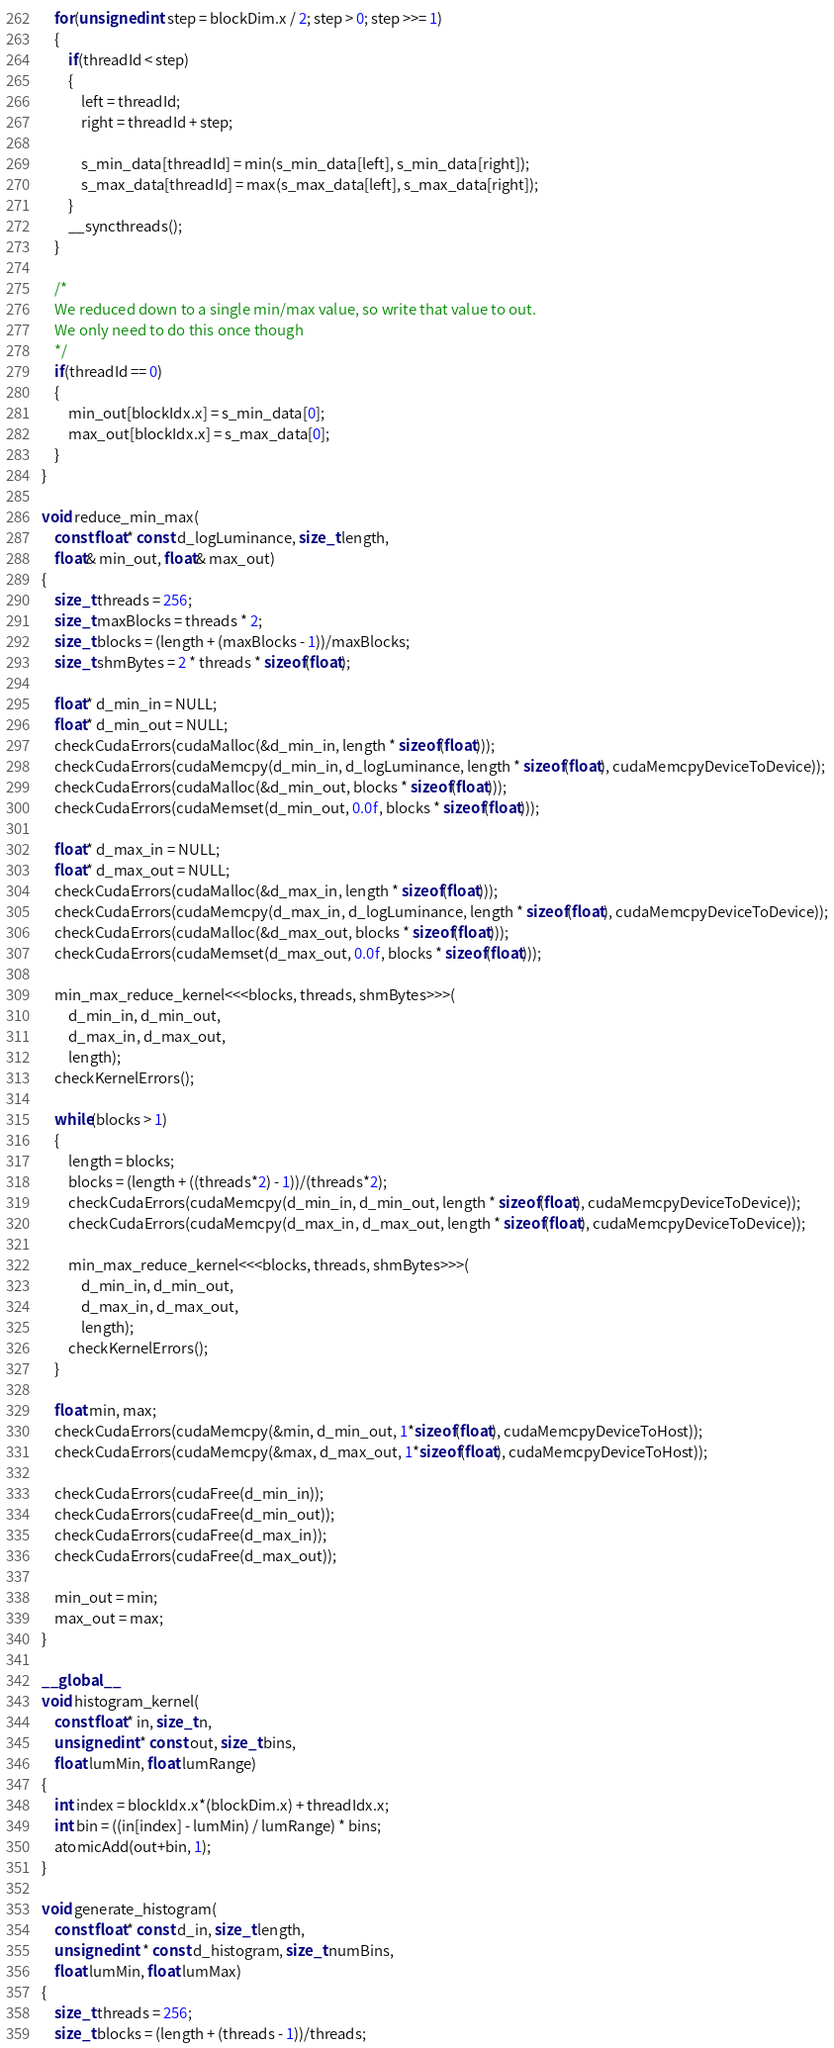<code> <loc_0><loc_0><loc_500><loc_500><_Cuda_>    for(unsigned int step = blockDim.x / 2; step > 0; step >>= 1)
    {
        if(threadId < step)
        {
            left = threadId;
            right = threadId + step;

            s_min_data[threadId] = min(s_min_data[left], s_min_data[right]);
            s_max_data[threadId] = max(s_max_data[left], s_max_data[right]);
        }
        __syncthreads();
    }

    /*
    We reduced down to a single min/max value, so write that value to out.
    We only need to do this once though
    */
    if(threadId == 0)
    {
        min_out[blockIdx.x] = s_min_data[0];
        max_out[blockIdx.x] = s_max_data[0];
    }
}

void reduce_min_max(
    const float* const d_logLuminance, size_t length,
    float& min_out, float& max_out)
{
    size_t threads = 256;
    size_t maxBlocks = threads * 2;
    size_t blocks = (length + (maxBlocks - 1))/maxBlocks;
    size_t shmBytes = 2 * threads * sizeof(float);

    float* d_min_in = NULL;
    float* d_min_out = NULL;
    checkCudaErrors(cudaMalloc(&d_min_in, length * sizeof(float)));
    checkCudaErrors(cudaMemcpy(d_min_in, d_logLuminance, length * sizeof(float), cudaMemcpyDeviceToDevice));
    checkCudaErrors(cudaMalloc(&d_min_out, blocks * sizeof(float)));
    checkCudaErrors(cudaMemset(d_min_out, 0.0f, blocks * sizeof(float)));

    float* d_max_in = NULL;
    float* d_max_out = NULL;
    checkCudaErrors(cudaMalloc(&d_max_in, length * sizeof(float)));
    checkCudaErrors(cudaMemcpy(d_max_in, d_logLuminance, length * sizeof(float), cudaMemcpyDeviceToDevice));
    checkCudaErrors(cudaMalloc(&d_max_out, blocks * sizeof(float)));
    checkCudaErrors(cudaMemset(d_max_out, 0.0f, blocks * sizeof(float)));

    min_max_reduce_kernel<<<blocks, threads, shmBytes>>>(
        d_min_in, d_min_out,
        d_max_in, d_max_out,
        length);
    checkKernelErrors();

    while(blocks > 1)
    {
        length = blocks;
        blocks = (length + ((threads*2) - 1))/(threads*2);
        checkCudaErrors(cudaMemcpy(d_min_in, d_min_out, length * sizeof(float), cudaMemcpyDeviceToDevice));
        checkCudaErrors(cudaMemcpy(d_max_in, d_max_out, length * sizeof(float), cudaMemcpyDeviceToDevice));

        min_max_reduce_kernel<<<blocks, threads, shmBytes>>>(
            d_min_in, d_min_out,
            d_max_in, d_max_out,
            length);
        checkKernelErrors();
    }

    float min, max;
    checkCudaErrors(cudaMemcpy(&min, d_min_out, 1*sizeof(float), cudaMemcpyDeviceToHost));
    checkCudaErrors(cudaMemcpy(&max, d_max_out, 1*sizeof(float), cudaMemcpyDeviceToHost));

    checkCudaErrors(cudaFree(d_min_in));
    checkCudaErrors(cudaFree(d_min_out));
    checkCudaErrors(cudaFree(d_max_in));
    checkCudaErrors(cudaFree(d_max_out));

    min_out = min;
    max_out = max;
}

__global__
void histogram_kernel(
    const float* in, size_t n,
    unsigned int* const out, size_t bins,
    float lumMin, float lumRange)
{
    int index = blockIdx.x*(blockDim.x) + threadIdx.x;
    int bin = ((in[index] - lumMin) / lumRange) * bins;
    atomicAdd(out+bin, 1);
}

void generate_histogram(
    const float* const d_in, size_t length,
    unsigned int * const d_histogram, size_t numBins,
    float lumMin, float lumMax)
{
    size_t threads = 256;
    size_t blocks = (length + (threads - 1))/threads;
</code> 